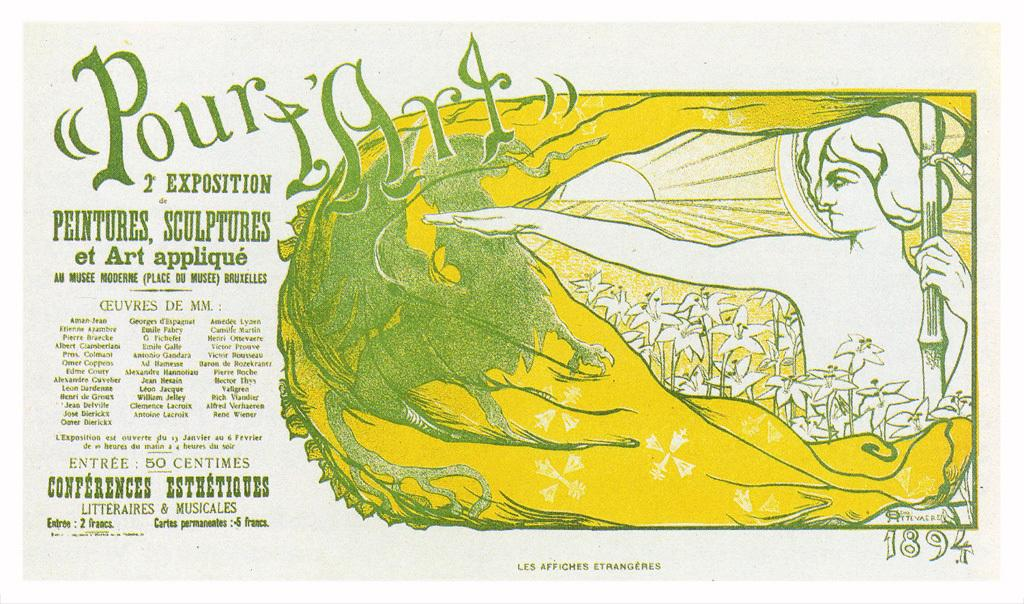<image>
Offer a succinct explanation of the picture presented. The entry price to this shown is 50 Centimes. 